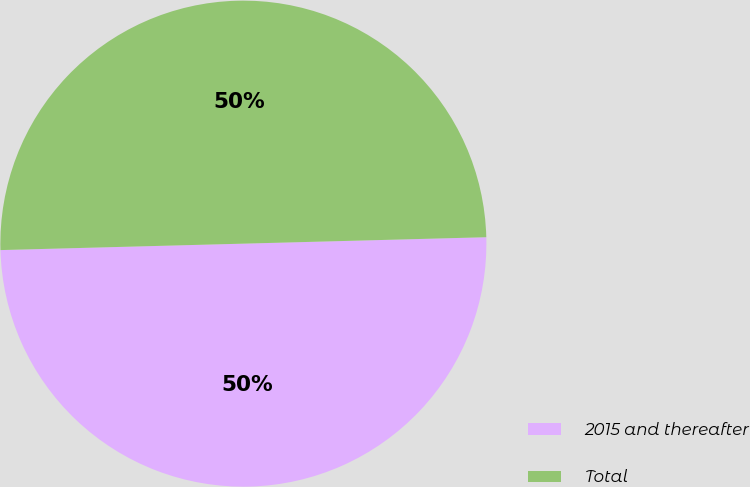Convert chart. <chart><loc_0><loc_0><loc_500><loc_500><pie_chart><fcel>2015 and thereafter<fcel>Total<nl><fcel>50.0%<fcel>50.0%<nl></chart> 